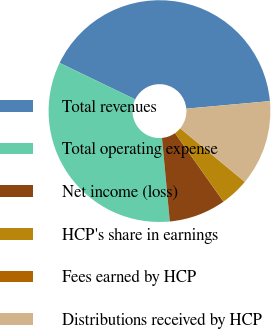Convert chart. <chart><loc_0><loc_0><loc_500><loc_500><pie_chart><fcel>Total revenues<fcel>Total operating expense<fcel>Net income (loss)<fcel>HCP's share in earnings<fcel>Fees earned by HCP<fcel>Distributions received by HCP<nl><fcel>41.41%<fcel>33.64%<fcel>8.31%<fcel>4.17%<fcel>0.03%<fcel>12.44%<nl></chart> 